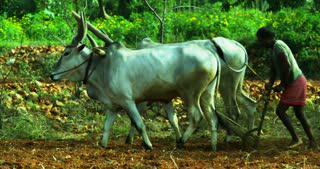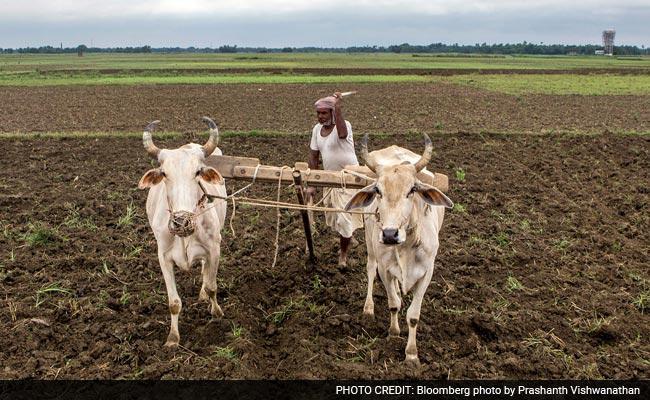The first image is the image on the left, the second image is the image on the right. For the images displayed, is the sentence "One image shows two oxen pulling a two-wheeled cart forward on a road, and the other image shows a man standing behind a team of two oxen pulling a plow on a dirt-turned field." factually correct? Answer yes or no. No. The first image is the image on the left, the second image is the image on the right. For the images displayed, is the sentence "Ox are pulling a cart with wheels." factually correct? Answer yes or no. No. 